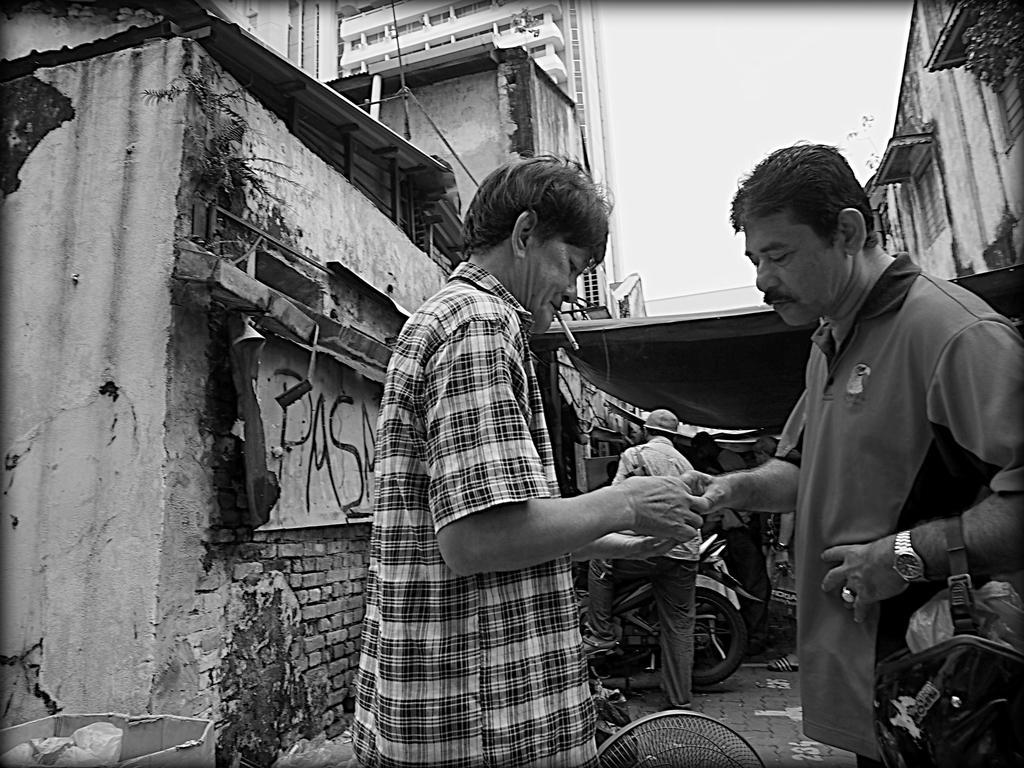Could you give a brief overview of what you see in this image? This is a black and white image. On the right side there are two men holding some object in their hands and looking at the object. The man who is on the right side is holding a bag. At the back of these people there are few houses and few people are standing on the ground and also there is a vehicle. On the left side there is box which is placed on the ground. At the top of the image I can see the sky. 